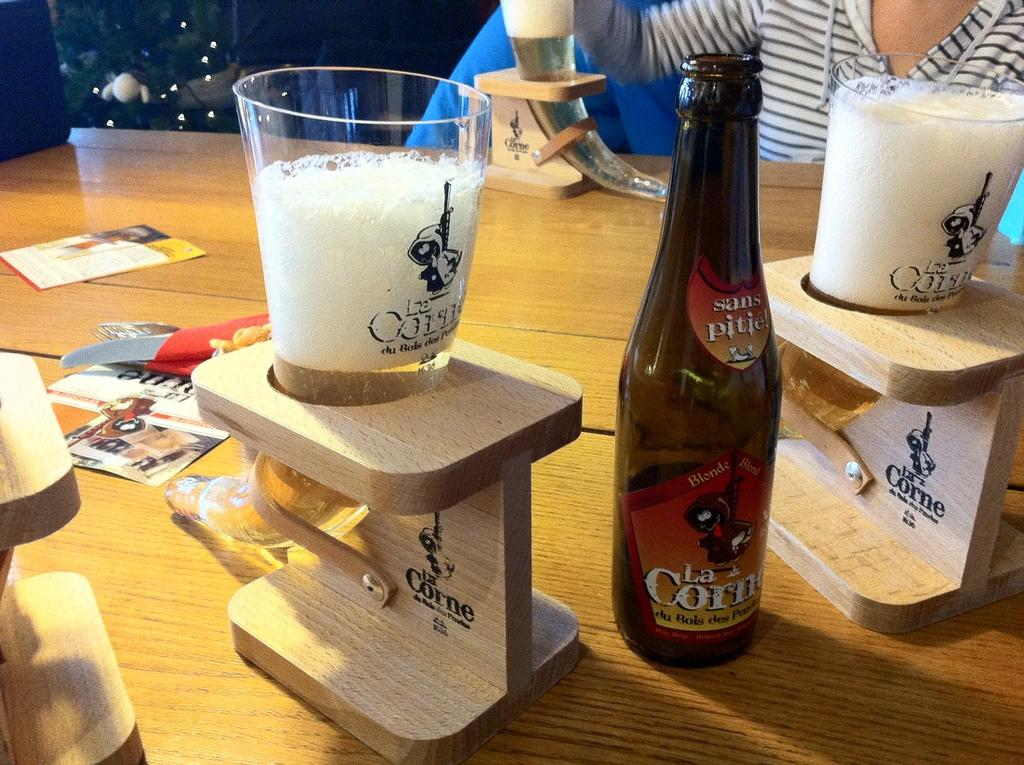Provide a one-sentence caption for the provided image. many horned shaped glasses and one bottle of La Corne on a table. 